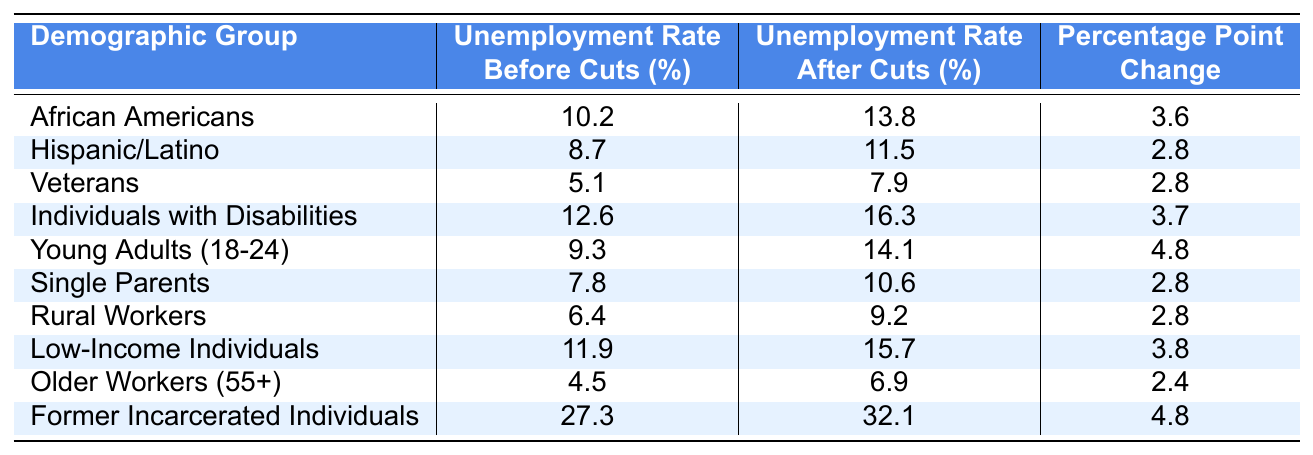What is the unemployment rate for African Americans before the cuts? The table shows the unemployment rate for African Americans before the cuts as 10.2%.
Answer: 10.2% What is the unemployment rate for Low-Income Individuals after the cuts? The table indicates that the unemployment rate for Low-Income Individuals after the cuts is 15.7%.
Answer: 15.7% Which demographic group experienced the highest percentage point change in unemployment rate after the cuts? By reviewing the "Percentage Point Change" column, the group with the highest change is "Former Incarcerated Individuals" with a change of 4.8 percentage points.
Answer: Former Incarcerated Individuals What was the percentage point change in unemployment for Older Workers (55+)? The table specifies the "Percentage Point Change" for Older Workers (55+) is 2.4.
Answer: 2.4 Did the unemployment rate for Veterans increase after the cuts? According to the table, the unemployment rate for Veterans increased from 5.1% to 7.9% after the cuts, confirming it did increase.
Answer: Yes What is the average unemployment rate after cuts for all groups listed? To find the average, sum the unemployment rates after cuts: (13.8 + 11.5 + 7.9 + 16.3 + 14.1 + 10.6 + 9.2 + 15.7 + 6.9 + 32.1) =  7.3, and divide by 10 groups. The average rate is 12.1%.
Answer: 12.1% How many groups had an unemployment rate increase higher than 3% after the cuts? By reviewing the "Percentage Point Change" column for values greater than 3, we find African Americans (3.6), Individuals with Disabilities (3.7), Young Adults (4.8), Low-Income Individuals (3.8), and Former Incarcerated Individuals (4.8), totaling 5 groups.
Answer: 5 What is the total increase in unemployment rates for all demographic groups combined? To find the total increase, sum up all the "Percentage Point Change" values: 3.6 + 2.8 + 2.8 + 3.7 + 4.8 + 2.8 + 2.8 + 3.8 + 2.4 + 4.8 =  33.5 percentage points.
Answer: 33.5 Is the unemployment rate for Young Adults (18-24) after the cuts higher than that of Veterans? The unemployment rate after cuts for Young Adults (14.1%) is compared to Veterans (7.9%), and since 14.1% is greater than 7.9%, the statement is true.
Answer: Yes What is the percentage point change for Single Parents? The table states the percentage point change for Single Parents is 2.8.
Answer: 2.8 